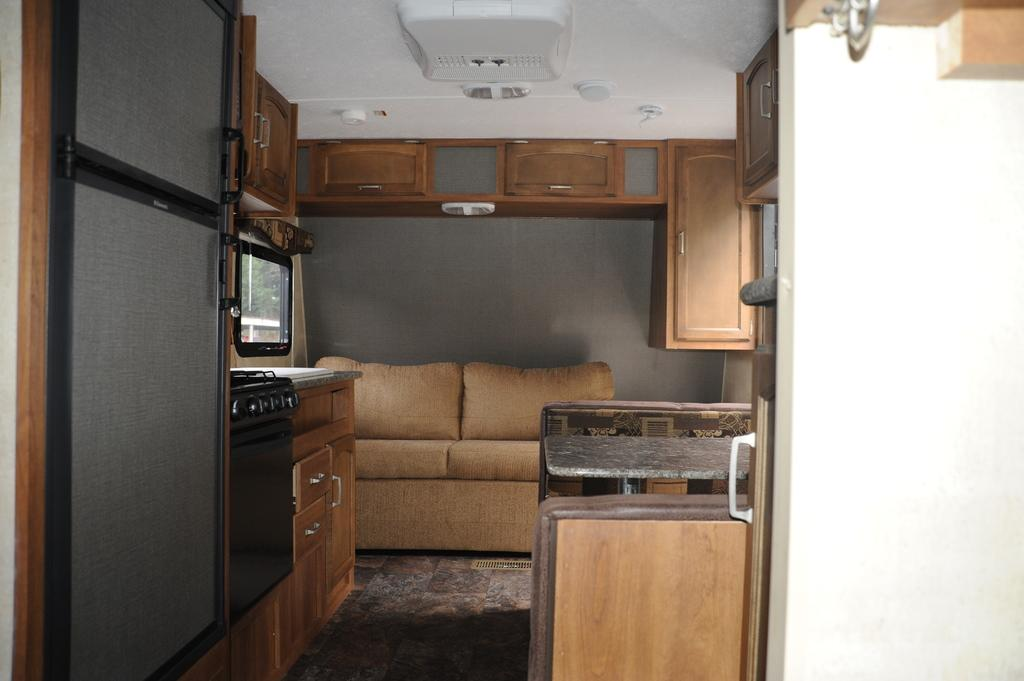What type of furniture is in the room? There is a sofa in the room. Where is the desk located in the room? The desk is on the right side of the room. What can be used for storage in the room? There are shelves in the room for storage. What part of the room can be seen in the image? The floor in the kitchen area is visible. What type of park can be seen through the window in the image? There is no window or park visible in the image. How many trays are on the desk in the image? There is no tray present on the desk in the image. 